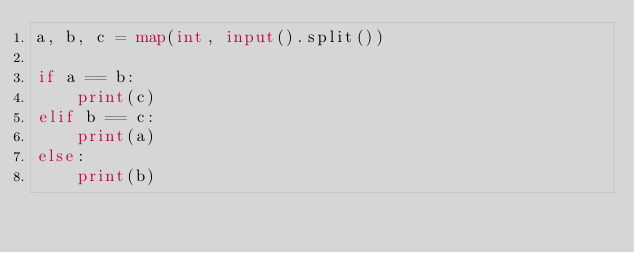Convert code to text. <code><loc_0><loc_0><loc_500><loc_500><_Python_>a, b, c = map(int, input().split())

if a == b:
    print(c)
elif b == c:
    print(a)
else:
    print(b)
</code> 